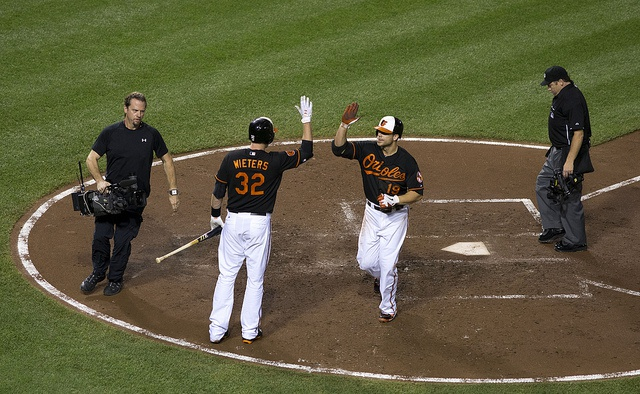Describe the objects in this image and their specific colors. I can see people in darkgreen, lavender, black, and gray tones, people in darkgreen, black, olive, gray, and tan tones, people in darkgreen, black, lavender, and gray tones, people in darkgreen, black, and gray tones, and baseball bat in darkgreen, black, gray, and ivory tones in this image. 